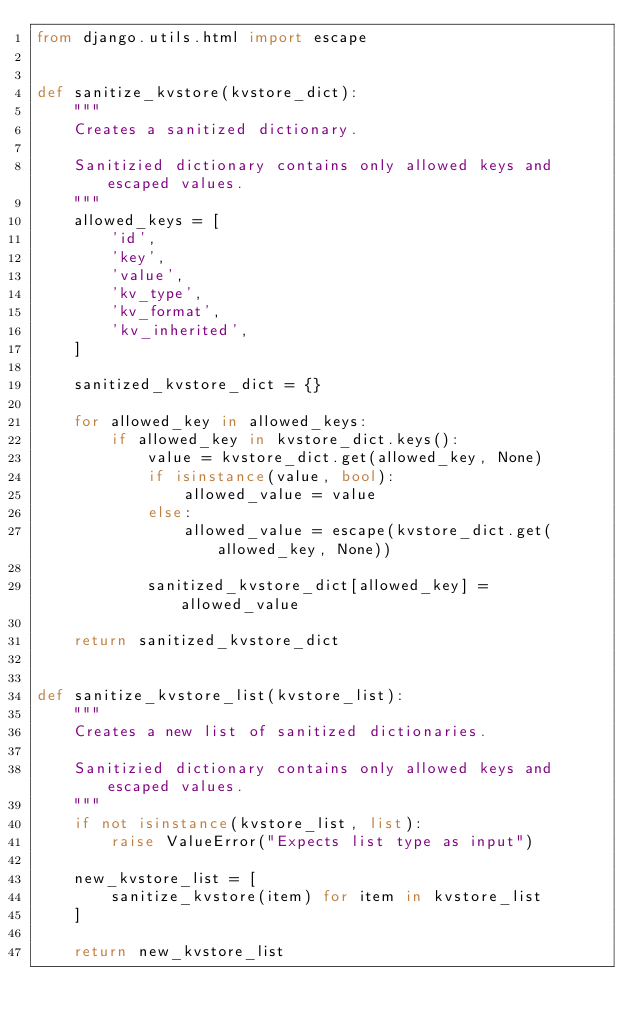Convert code to text. <code><loc_0><loc_0><loc_500><loc_500><_Python_>from django.utils.html import escape


def sanitize_kvstore(kvstore_dict):
    """
    Creates a sanitized dictionary.

    Sanitizied dictionary contains only allowed keys and escaped values.
    """
    allowed_keys = [
        'id',
        'key',
        'value',
        'kv_type',
        'kv_format',
        'kv_inherited',
    ]

    sanitized_kvstore_dict = {}

    for allowed_key in allowed_keys:
        if allowed_key in kvstore_dict.keys():
            value = kvstore_dict.get(allowed_key, None)
            if isinstance(value, bool):
                allowed_value = value
            else:
                allowed_value = escape(kvstore_dict.get(allowed_key, None))

            sanitized_kvstore_dict[allowed_key] = allowed_value

    return sanitized_kvstore_dict


def sanitize_kvstore_list(kvstore_list):
    """
    Creates a new list of sanitized dictionaries.

    Sanitizied dictionary contains only allowed keys and escaped values.
    """
    if not isinstance(kvstore_list, list):
        raise ValueError("Expects list type as input")

    new_kvstore_list = [
        sanitize_kvstore(item) for item in kvstore_list
    ]

    return new_kvstore_list
</code> 